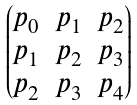Convert formula to latex. <formula><loc_0><loc_0><loc_500><loc_500>\begin{pmatrix} p _ { 0 } & p _ { 1 } & p _ { 2 } \\ p _ { 1 } & p _ { 2 } & p _ { 3 } \\ p _ { 2 } & p _ { 3 } & p _ { 4 } \\ \end{pmatrix}</formula> 